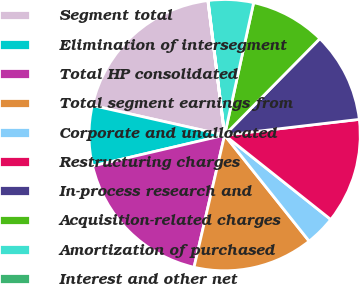Convert chart to OTSL. <chart><loc_0><loc_0><loc_500><loc_500><pie_chart><fcel>Segment total<fcel>Elimination of intersegment<fcel>Total HP consolidated<fcel>Total segment earnings from<fcel>Corporate and unallocated<fcel>Restructuring charges<fcel>In-process research and<fcel>Acquisition-related charges<fcel>Amortization of purchased<fcel>Interest and other net<nl><fcel>19.51%<fcel>7.17%<fcel>17.72%<fcel>14.33%<fcel>3.6%<fcel>12.54%<fcel>10.75%<fcel>8.96%<fcel>5.38%<fcel>0.02%<nl></chart> 